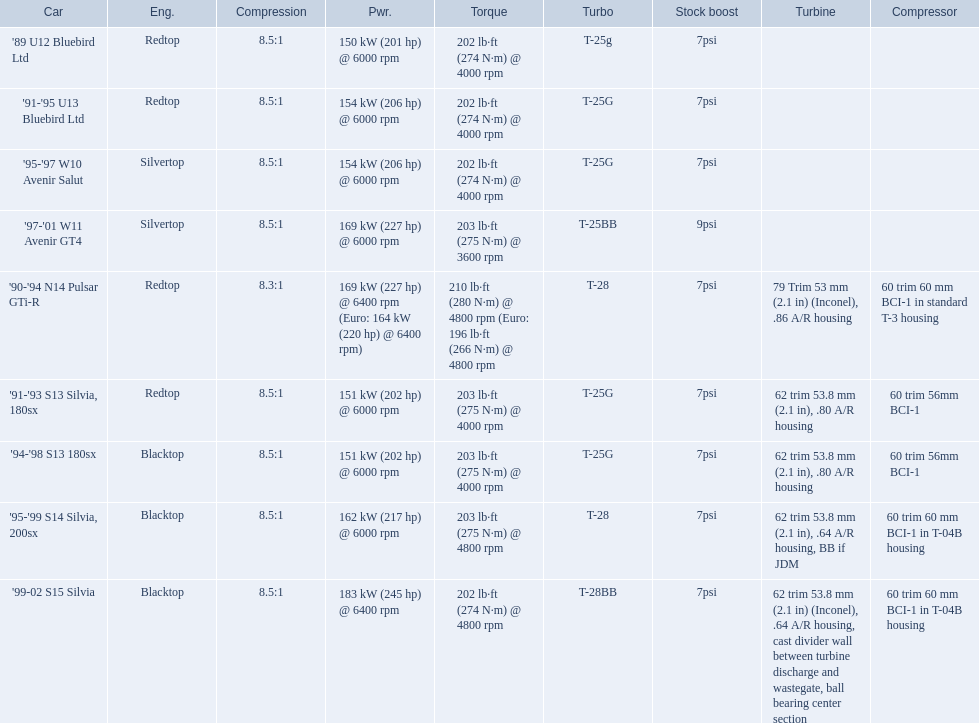What are the listed hp of the cars? 150 kW (201 hp) @ 6000 rpm, 154 kW (206 hp) @ 6000 rpm, 154 kW (206 hp) @ 6000 rpm, 169 kW (227 hp) @ 6000 rpm, 169 kW (227 hp) @ 6400 rpm (Euro: 164 kW (220 hp) @ 6400 rpm), 151 kW (202 hp) @ 6000 rpm, 151 kW (202 hp) @ 6000 rpm, 162 kW (217 hp) @ 6000 rpm, 183 kW (245 hp) @ 6400 rpm. Which is the only car with over 230 hp? '99-02 S15 Silvia. What are all of the nissan cars? '89 U12 Bluebird Ltd, '91-'95 U13 Bluebird Ltd, '95-'97 W10 Avenir Salut, '97-'01 W11 Avenir GT4, '90-'94 N14 Pulsar GTi-R, '91-'93 S13 Silvia, 180sx, '94-'98 S13 180sx, '95-'99 S14 Silvia, 200sx, '99-02 S15 Silvia. Of these cars, which one is a '90-'94 n14 pulsar gti-r? '90-'94 N14 Pulsar GTi-R. What is the compression of this car? 8.3:1. 